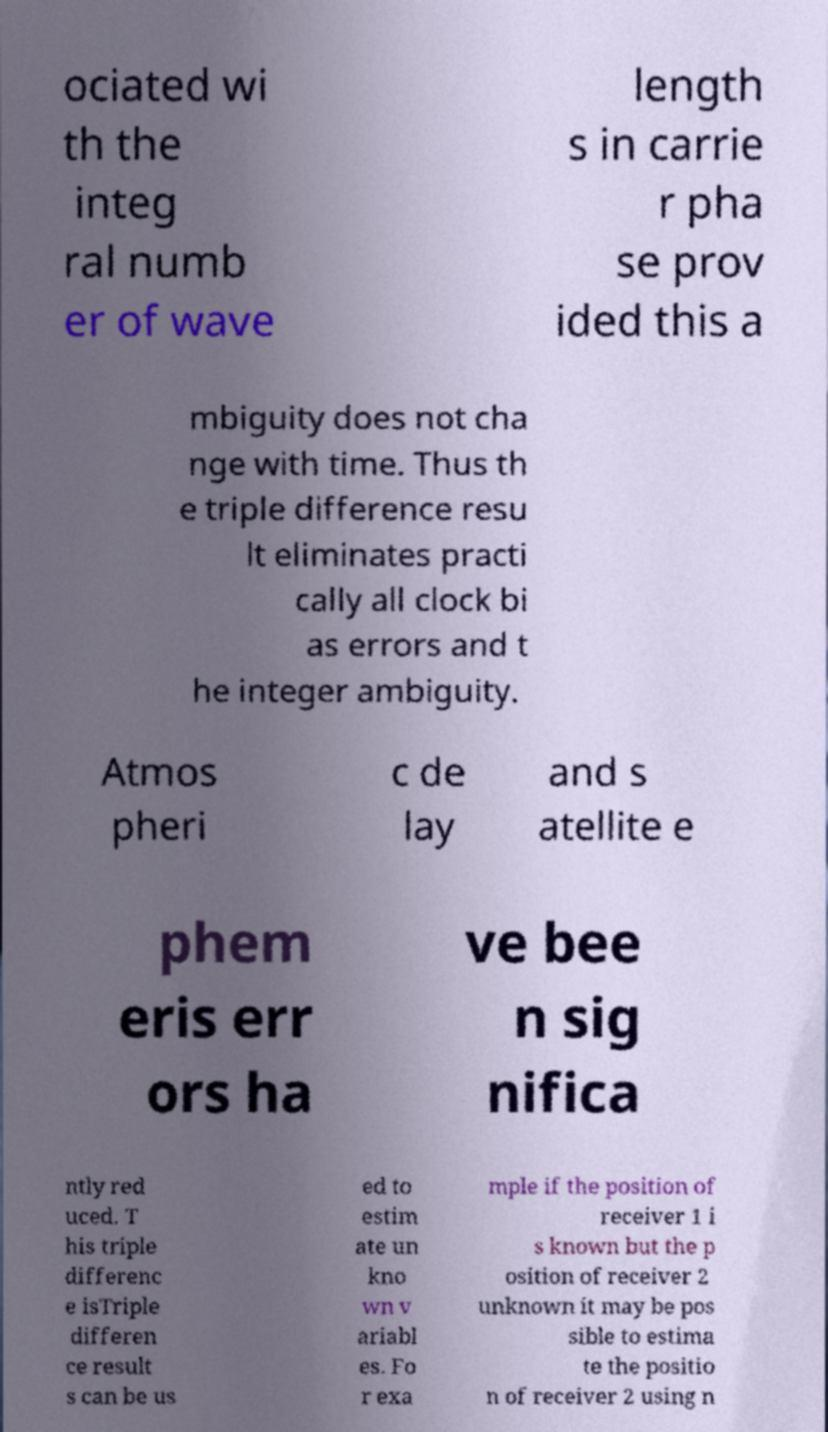Can you accurately transcribe the text from the provided image for me? ociated wi th the integ ral numb er of wave length s in carrie r pha se prov ided this a mbiguity does not cha nge with time. Thus th e triple difference resu lt eliminates practi cally all clock bi as errors and t he integer ambiguity. Atmos pheri c de lay and s atellite e phem eris err ors ha ve bee n sig nifica ntly red uced. T his triple differenc e isTriple differen ce result s can be us ed to estim ate un kno wn v ariabl es. Fo r exa mple if the position of receiver 1 i s known but the p osition of receiver 2 unknown it may be pos sible to estima te the positio n of receiver 2 using n 